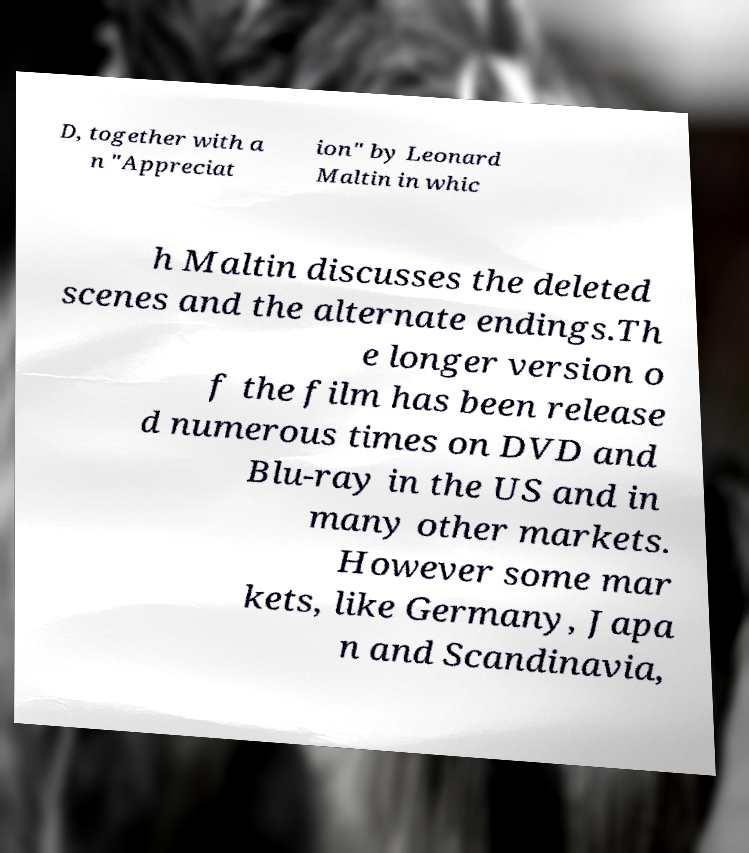Please identify and transcribe the text found in this image. D, together with a n "Appreciat ion" by Leonard Maltin in whic h Maltin discusses the deleted scenes and the alternate endings.Th e longer version o f the film has been release d numerous times on DVD and Blu-ray in the US and in many other markets. However some mar kets, like Germany, Japa n and Scandinavia, 